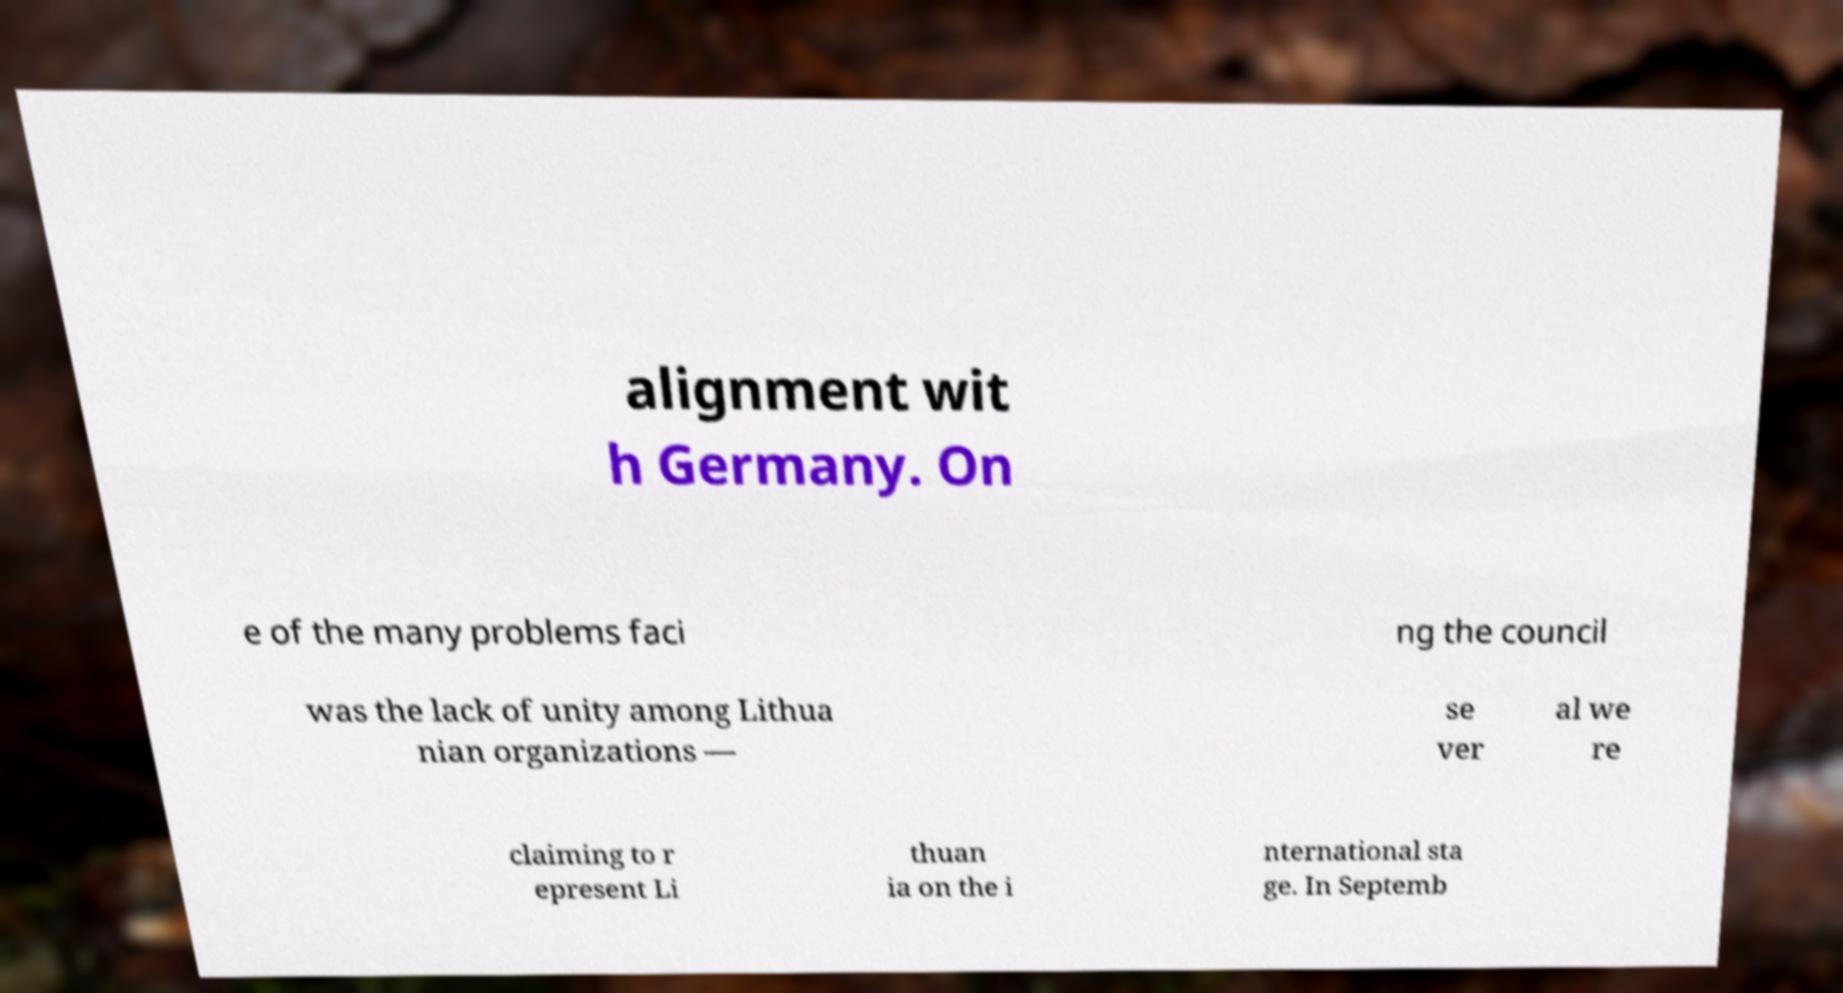Please identify and transcribe the text found in this image. alignment wit h Germany. On e of the many problems faci ng the council was the lack of unity among Lithua nian organizations — se ver al we re claiming to r epresent Li thuan ia on the i nternational sta ge. In Septemb 